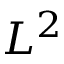Convert formula to latex. <formula><loc_0><loc_0><loc_500><loc_500>L ^ { 2 }</formula> 